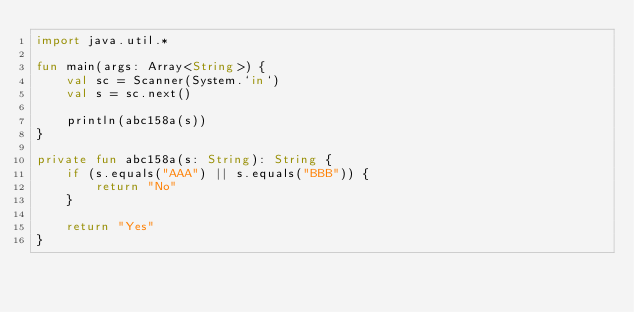Convert code to text. <code><loc_0><loc_0><loc_500><loc_500><_Kotlin_>import java.util.*

fun main(args: Array<String>) {
    val sc = Scanner(System.`in`)
    val s = sc.next()

    println(abc158a(s))
}

private fun abc158a(s: String): String {
    if (s.equals("AAA") || s.equals("BBB")) {
        return "No"
    }

    return "Yes"
}</code> 